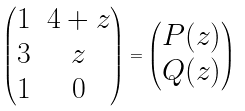<formula> <loc_0><loc_0><loc_500><loc_500>\begin{pmatrix} 1 & 4 + z \\ 3 & z \\ 1 & 0 \end{pmatrix} = \begin{pmatrix} P ( z ) \\ Q ( z ) \end{pmatrix}</formula> 